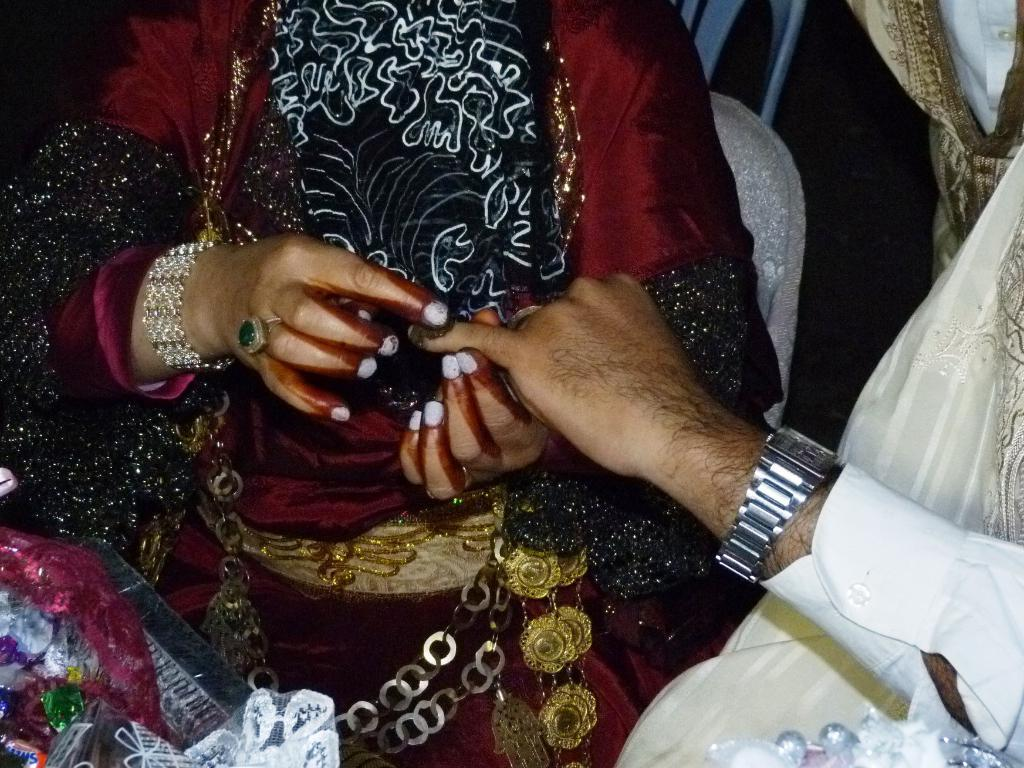Who are the people in the image? There is a woman and a man in the image. What is the woman doing with the man? The woman is holding the finger of the man. What accessory is the man wearing? The man is wearing a watch. What type of metal can be seen in the image? There is no metal visible in the image. How many groups of people are present in the image? There is only one group of people in the image, which consists of the woman and the man. 